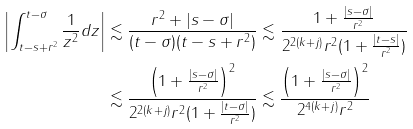<formula> <loc_0><loc_0><loc_500><loc_500>\left | \int _ { t - s + r ^ { 2 } } ^ { t - \sigma } \frac { 1 } { z ^ { 2 } } d z \right | & \lesssim \frac { r ^ { 2 } + | s - \sigma | } { ( t - \sigma ) ( t - s + r ^ { 2 } ) } \lesssim \frac { 1 + \frac { | s - \sigma | } { r ^ { 2 } } } { 2 ^ { 2 ( k + j ) } r ^ { 2 } ( 1 + \frac { | t - s | } { r ^ { 2 } } ) } \\ & \lesssim \frac { \left ( 1 + \frac { | s - \sigma | } { r ^ { 2 } } \right ) ^ { 2 } } { 2 ^ { 2 ( k + j ) } r ^ { 2 } ( 1 + \frac { | t - \sigma | } { r ^ { 2 } } ) } \lesssim \frac { \left ( 1 + \frac { | s - \sigma | } { r ^ { 2 } } \right ) ^ { 2 } } { 2 ^ { 4 ( k + j ) } r ^ { 2 } }</formula> 